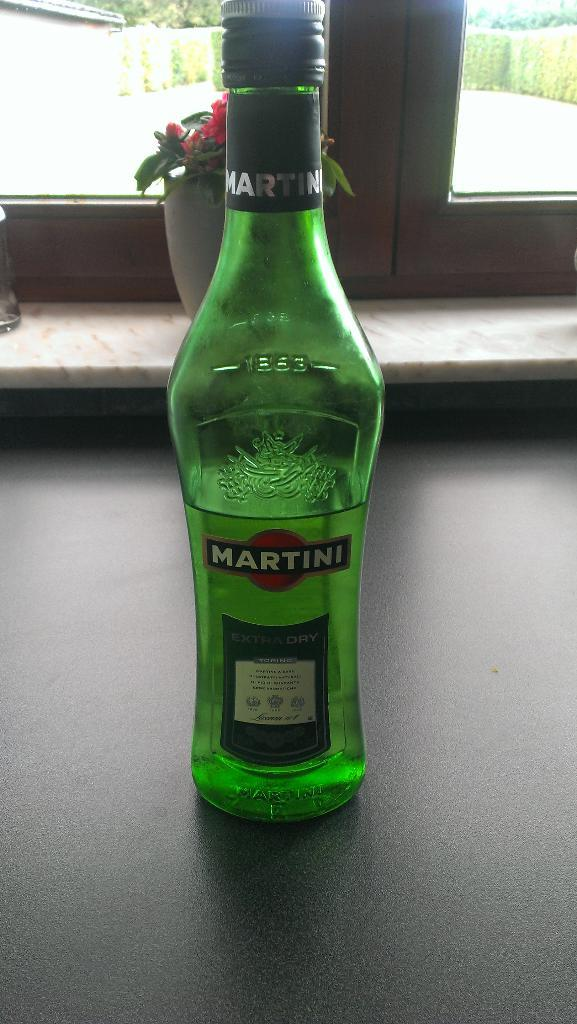<image>
Give a short and clear explanation of the subsequent image. A green Martini bottle of extra dry liquor on a counter by a window. 